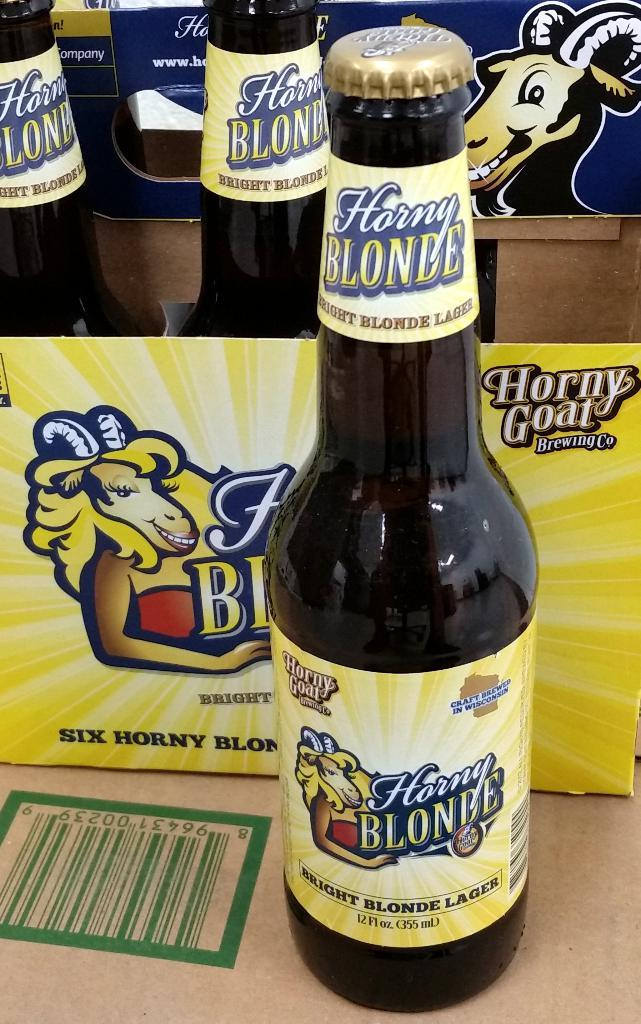<image>
Relay a brief, clear account of the picture shown. A bottle of Horny Blonde ale in front of a case of the same ale. 